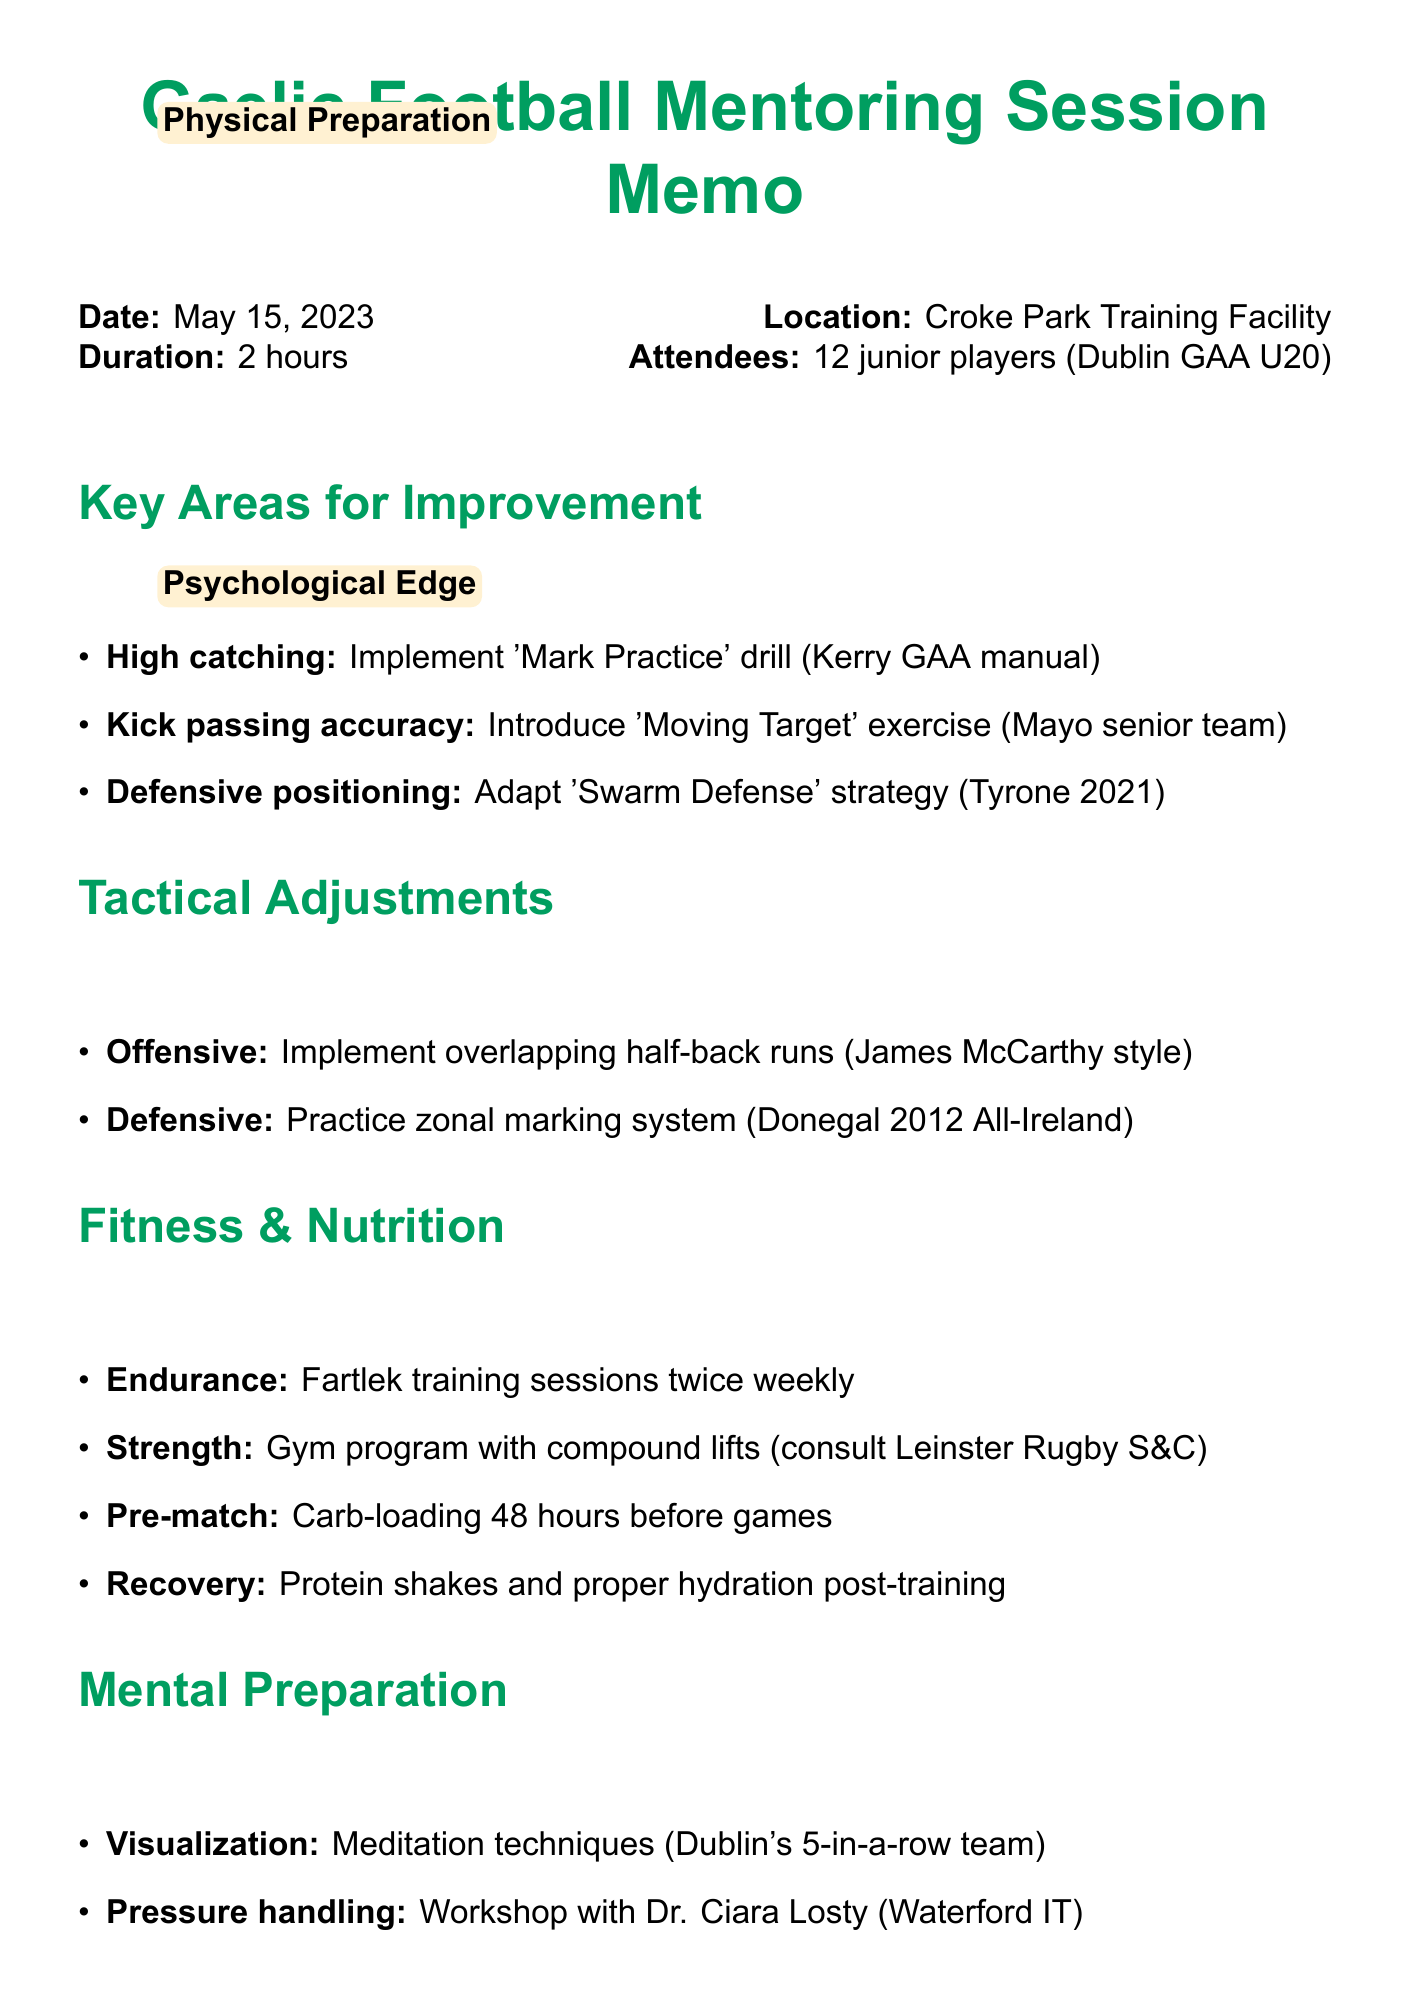What is the date of the mentoring session? The date is explicitly mentioned in the document as May 15, 2023.
Answer: May 15, 2023 Where was the mentoring session held? The location of the session is stated in the document as Croke Park Training Facility.
Answer: Croke Park Training Facility How many junior players attended the session? The document indicates that 12 junior players attended the mentoring session.
Answer: 12 What skill is related to players struggling with timing and positioning? The document states that High catching is the skill related to this observation.
Answer: High catching What drill is recommended for improving kick passing accuracy? The memo suggests introducing the 'Moving Target' exercise from the Mayo senior team for this improvement.
Answer: 'Moving Target' exercise What is one area of improvement noted for Ciarán O'Sullivan? The memo records that he needs to work on left-foot kicking.
Answer: Left-foot kicking What tactical adjustment is suggested for the offensive strategy? The document mentions implementing overlapping half-back runs similar to James McCarthy's style.
Answer: Overlapping half-back runs What is the recommended frequency for Fartlek training sessions? The document states that Fartlek training sessions should be incorporated twice a week.
Answer: Twice a week Who is recommended to conduct a workshop on pressure handling? The document mentions Dr. Ciara Losty from Waterford IT as the recommended facilitator for this workshop.
Answer: Dr. Ciara Losty 